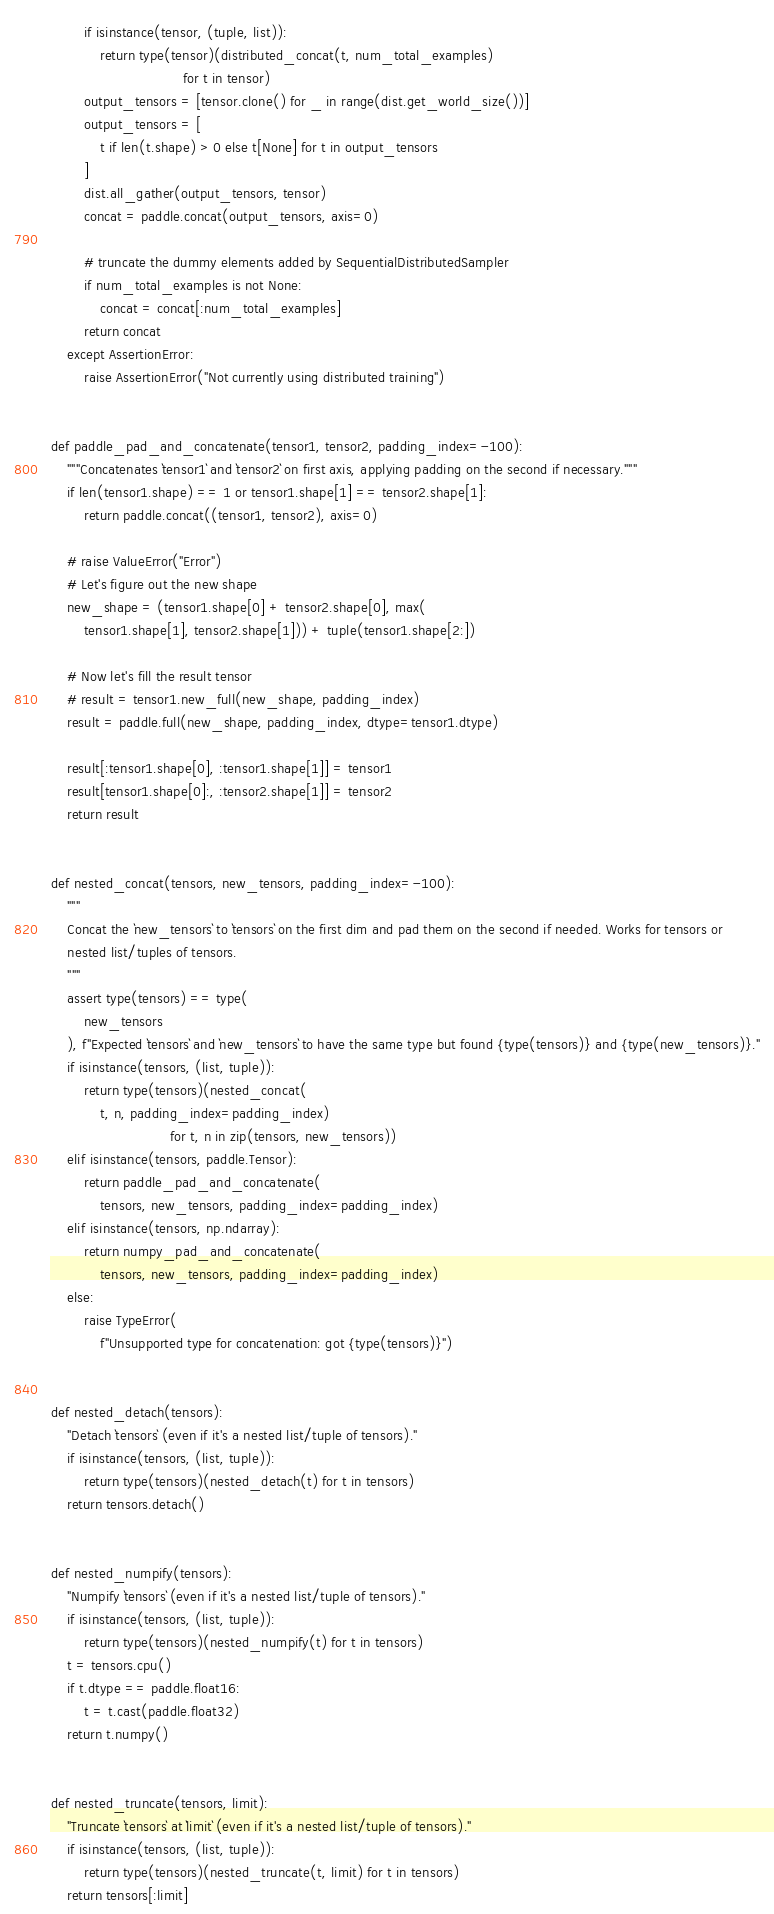Convert code to text. <code><loc_0><loc_0><loc_500><loc_500><_Python_>        if isinstance(tensor, (tuple, list)):
            return type(tensor)(distributed_concat(t, num_total_examples)
                                for t in tensor)
        output_tensors = [tensor.clone() for _ in range(dist.get_world_size())]
        output_tensors = [
            t if len(t.shape) > 0 else t[None] for t in output_tensors
        ]
        dist.all_gather(output_tensors, tensor)
        concat = paddle.concat(output_tensors, axis=0)

        # truncate the dummy elements added by SequentialDistributedSampler
        if num_total_examples is not None:
            concat = concat[:num_total_examples]
        return concat
    except AssertionError:
        raise AssertionError("Not currently using distributed training")


def paddle_pad_and_concatenate(tensor1, tensor2, padding_index=-100):
    """Concatenates `tensor1` and `tensor2` on first axis, applying padding on the second if necessary."""
    if len(tensor1.shape) == 1 or tensor1.shape[1] == tensor2.shape[1]:
        return paddle.concat((tensor1, tensor2), axis=0)

    # raise ValueError("Error")
    # Let's figure out the new shape
    new_shape = (tensor1.shape[0] + tensor2.shape[0], max(
        tensor1.shape[1], tensor2.shape[1])) + tuple(tensor1.shape[2:])

    # Now let's fill the result tensor
    # result = tensor1.new_full(new_shape, padding_index)
    result = paddle.full(new_shape, padding_index, dtype=tensor1.dtype)

    result[:tensor1.shape[0], :tensor1.shape[1]] = tensor1
    result[tensor1.shape[0]:, :tensor2.shape[1]] = tensor2
    return result


def nested_concat(tensors, new_tensors, padding_index=-100):
    """
    Concat the `new_tensors` to `tensors` on the first dim and pad them on the second if needed. Works for tensors or
    nested list/tuples of tensors.
    """
    assert type(tensors) == type(
        new_tensors
    ), f"Expected `tensors` and `new_tensors` to have the same type but found {type(tensors)} and {type(new_tensors)}."
    if isinstance(tensors, (list, tuple)):
        return type(tensors)(nested_concat(
            t, n, padding_index=padding_index)
                             for t, n in zip(tensors, new_tensors))
    elif isinstance(tensors, paddle.Tensor):
        return paddle_pad_and_concatenate(
            tensors, new_tensors, padding_index=padding_index)
    elif isinstance(tensors, np.ndarray):
        return numpy_pad_and_concatenate(
            tensors, new_tensors, padding_index=padding_index)
    else:
        raise TypeError(
            f"Unsupported type for concatenation: got {type(tensors)}")


def nested_detach(tensors):
    "Detach `tensors` (even if it's a nested list/tuple of tensors)."
    if isinstance(tensors, (list, tuple)):
        return type(tensors)(nested_detach(t) for t in tensors)
    return tensors.detach()


def nested_numpify(tensors):
    "Numpify `tensors` (even if it's a nested list/tuple of tensors)."
    if isinstance(tensors, (list, tuple)):
        return type(tensors)(nested_numpify(t) for t in tensors)
    t = tensors.cpu()
    if t.dtype == paddle.float16:
        t = t.cast(paddle.float32)
    return t.numpy()


def nested_truncate(tensors, limit):
    "Truncate `tensors` at `limit` (even if it's a nested list/tuple of tensors)."
    if isinstance(tensors, (list, tuple)):
        return type(tensors)(nested_truncate(t, limit) for t in tensors)
    return tensors[:limit]
</code> 